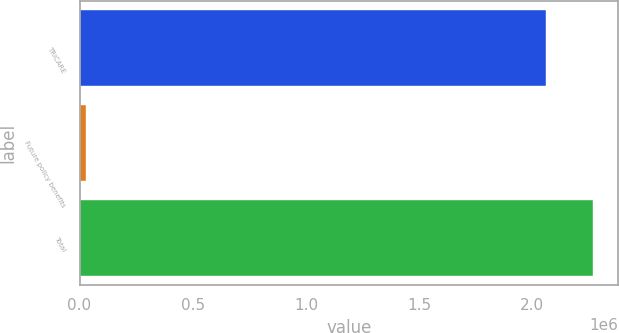Convert chart. <chart><loc_0><loc_0><loc_500><loc_500><bar_chart><fcel>TRICARE<fcel>Future policy benefits<fcel>Total<nl><fcel>2.06053e+06<fcel>28375<fcel>2.26658e+06<nl></chart> 